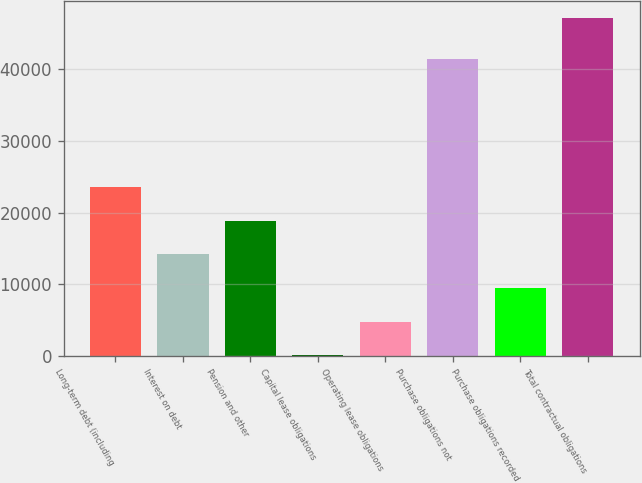Convert chart to OTSL. <chart><loc_0><loc_0><loc_500><loc_500><bar_chart><fcel>Long-term debt (including<fcel>Interest on debt<fcel>Pension and other<fcel>Capital lease obligations<fcel>Operating lease obligations<fcel>Purchase obligations not<fcel>Purchase obligations recorded<fcel>Total contractual obligations<nl><fcel>23606.5<fcel>14193.9<fcel>18900.2<fcel>75<fcel>4781.3<fcel>41470<fcel>9487.6<fcel>47138<nl></chart> 